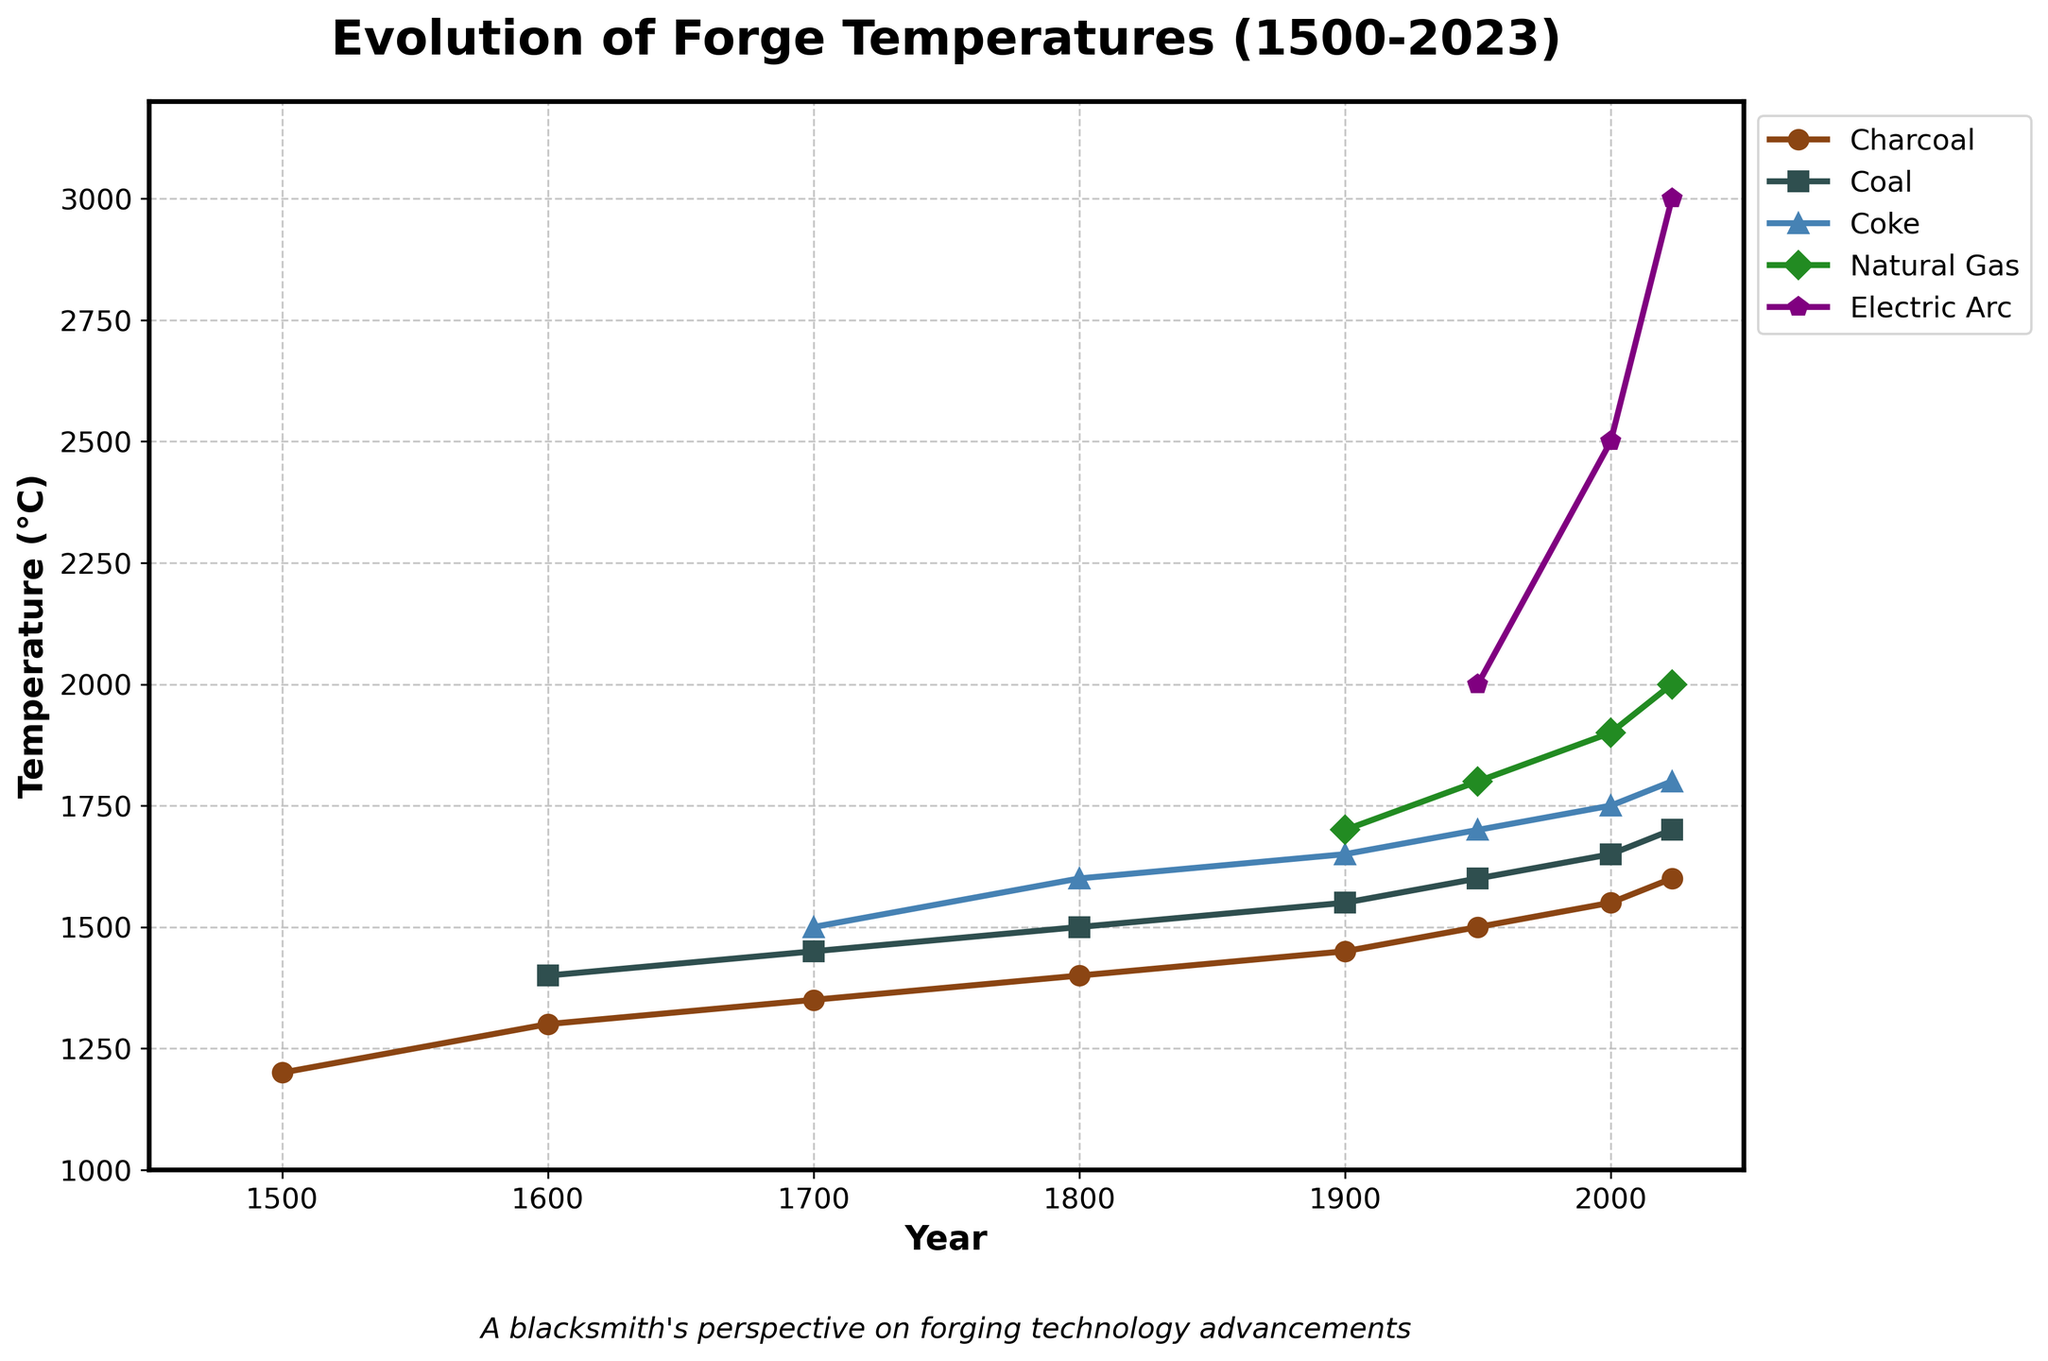What was the achievable forge temperature with charcoal in the year 1500? The data point for charcoal in the year 1500 is marked on the graph. Observing the y-axis value corresponding to charcoal in the year 1500, we find it is 1200°C.
Answer: 1200°C Which fuel type reached the highest temperature in 2023, and what was that temperature? Looking at the plot lines and the data points labeled for the year 2023, we can see that Electric Arc reached the highest temperature, which is 3000°C.
Answer: Electric Arc, 3000°C How much did the forge temperature achievable with coal increase from the year 1600 to 2000? In the year 1600, the temperature with coal was 1400°C. In 2000, it was 1650°C. The increase can be calculated as 1650 - 1400 = 250.
Answer: 250°C Between which years did the forge temperature with natural gas increase the most, and by how much? Observing the plot, natural gas temperatures increased from 1700°C in 1900 to 1900°C in 2000, and then to 2000°C in 2023. The highest increase is from 1900 to 2000, with an increase of 1900 - 1700 = 200°C.
Answer: 1900 to 2000, 200°C Compare the forge temperatures achievable with charcoal and coke in the year 1700. Which was higher, and by how much? In 1700, charcoal achieved 1350°C while coke achieved 1500°C. Coke was higher by 1500 - 1350 = 150°C.
Answer: Coke, 150°C Which fuel type consistently shows the highest achievable temperatures throughout the timeline? Analyzing the trend across all years, Electric Arc shows the highest achievable temperatures across the timeline since 1900.
Answer: Electric Arc What is the average forge temperature achievable with charcoal from 1500 to 2023? The temperatures achievable with charcoal over the years are 1200, 1300, 1350, 1400, 1450, 1500, 1550, and 1600. Their average is (1200 + 1300 + 1350 + 1400 + 1450 + 1500 + 1550 + 1600) / 8 = 1418.75.
Answer: 1418.75°C Which two fuel types had the same achievable forge temperature in any given year? What was that year and temperature? The plot shows Coal and Coke achieved the same temperature of 1500°C in the year 1800.
Answer: Coal and Coke, 1800, 1500°C 